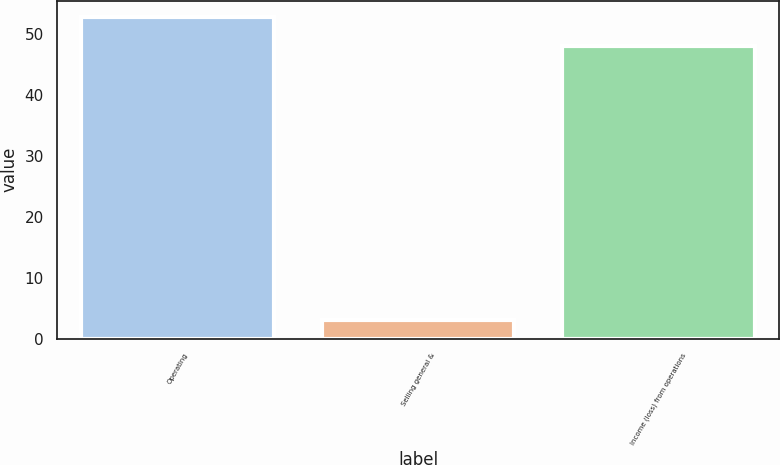<chart> <loc_0><loc_0><loc_500><loc_500><bar_chart><fcel>Operating<fcel>Selling general &<fcel>Income (loss) from operations<nl><fcel>52.8<fcel>3<fcel>48<nl></chart> 